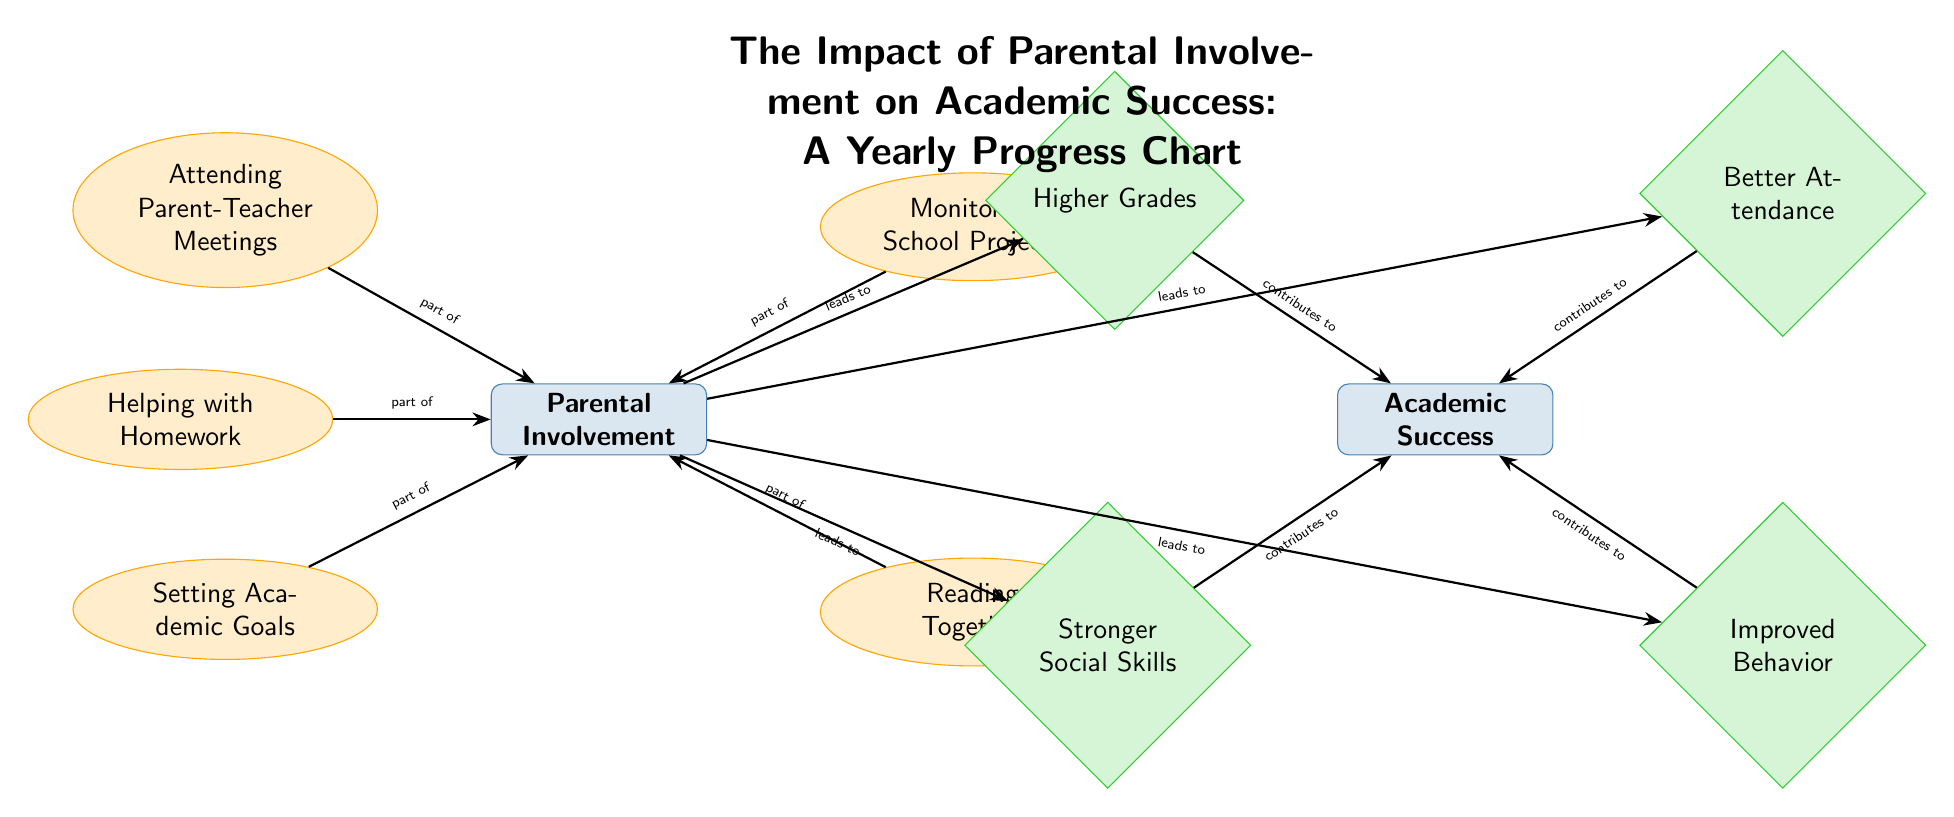What is the main category represented in the diagram? The main category is "Parental Involvement," which is the starting point of the diagram, indicating the primary focus of the chart in relation to academic success.
Answer: Parental Involvement How many outcomes are listed in the diagram? The diagram shows four outcomes related to academic success, which are connected to the central idea of parental involvement.
Answer: 4 What activity is linked to "Reading Together"? "Reading Together" is categorized as an activity under "Parental Involvement," and it stands out as one of the specific actions that can lead to academic success.
Answer: Parental Involvement Which outcome is directly related to "Higher Grades"? "Higher Grades" is positioned as an outcome that is influenced by parental involvement, showing a direct impact on a child’s academic success.
Answer: Academic Success What leads to "Improved Behavior"? "Improved Behavior" is an outcome that results from parental involvement, demonstrating how engagement in a child’s education can contribute to better behavioral outcomes.
Answer: Parental Involvement Which activities contribute to "Stronger Social Skills"? "Stronger Social Skills" is influenced by any of the activities shown under "Parental Involvement" such as Helping with Homework, Attending Parent-Teacher Meetings, etc.
Answer: All Activities If all activities are engaged in, what are the potential outcomes? Engaging in all activities can potentially lead to higher grades, better attendance, stronger social skills, and improved behavior, reflecting the comprehensive benefits of parental involvement.
Answer: All Outcomes What is the relationship between "Helping with Homework" and "Academic Success"? "Helping with Homework" is an activity that is part of parental involvement, and through this connection, it shows that such involvement can contribute to overall academic success.
Answer: Leads to Academic Success Which two outcomes are on the same horizontal level in the diagram? The outcomes "Higher Grades" and "Better Attendance" are located on the same horizontal level in the diagram, indicating they are considered equally important results of parental involvement.
Answer: Higher Grades and Better Attendance 